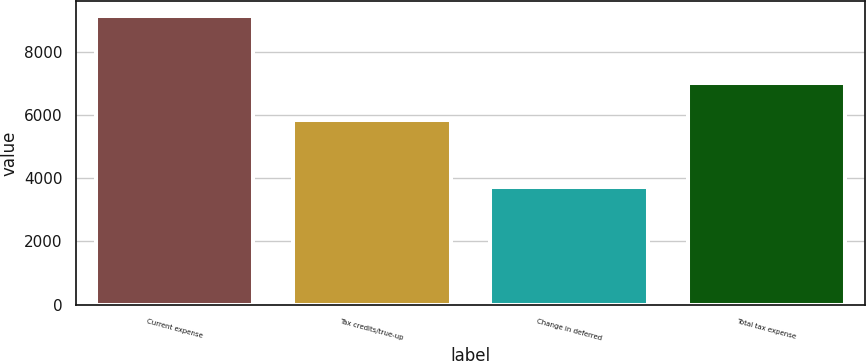Convert chart to OTSL. <chart><loc_0><loc_0><loc_500><loc_500><bar_chart><fcel>Current expense<fcel>Tax credits/true-up<fcel>Change in deferred<fcel>Total tax expense<nl><fcel>9136<fcel>5841<fcel>3730<fcel>7025<nl></chart> 